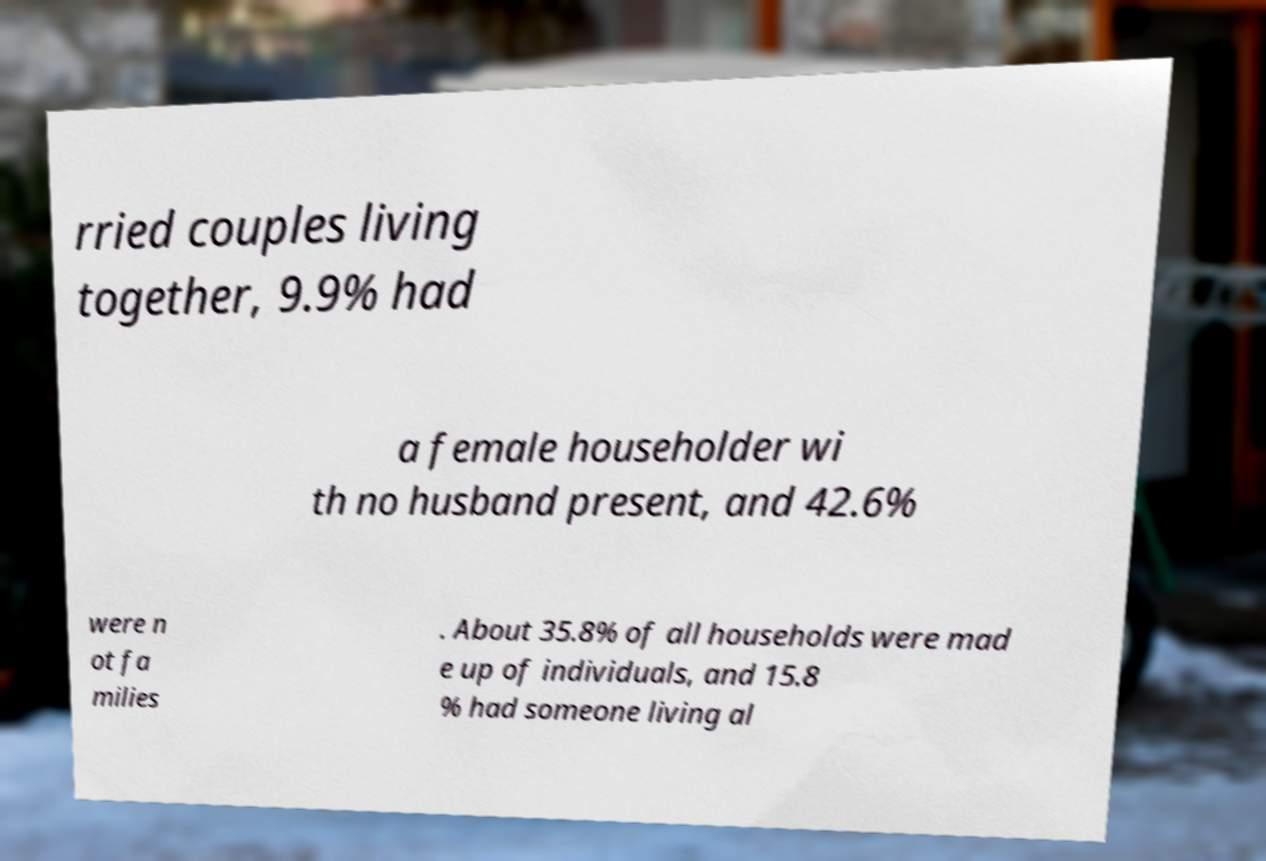Please identify and transcribe the text found in this image. rried couples living together, 9.9% had a female householder wi th no husband present, and 42.6% were n ot fa milies . About 35.8% of all households were mad e up of individuals, and 15.8 % had someone living al 